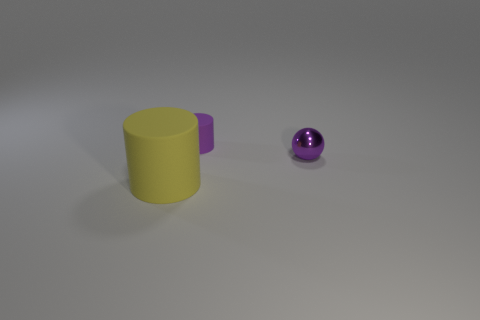Add 2 brown matte cylinders. How many objects exist? 5 Subtract all cylinders. How many objects are left? 1 Add 3 yellow objects. How many yellow objects are left? 4 Add 2 small cylinders. How many small cylinders exist? 3 Subtract 1 purple spheres. How many objects are left? 2 Subtract all big cyan cylinders. Subtract all big yellow matte objects. How many objects are left? 2 